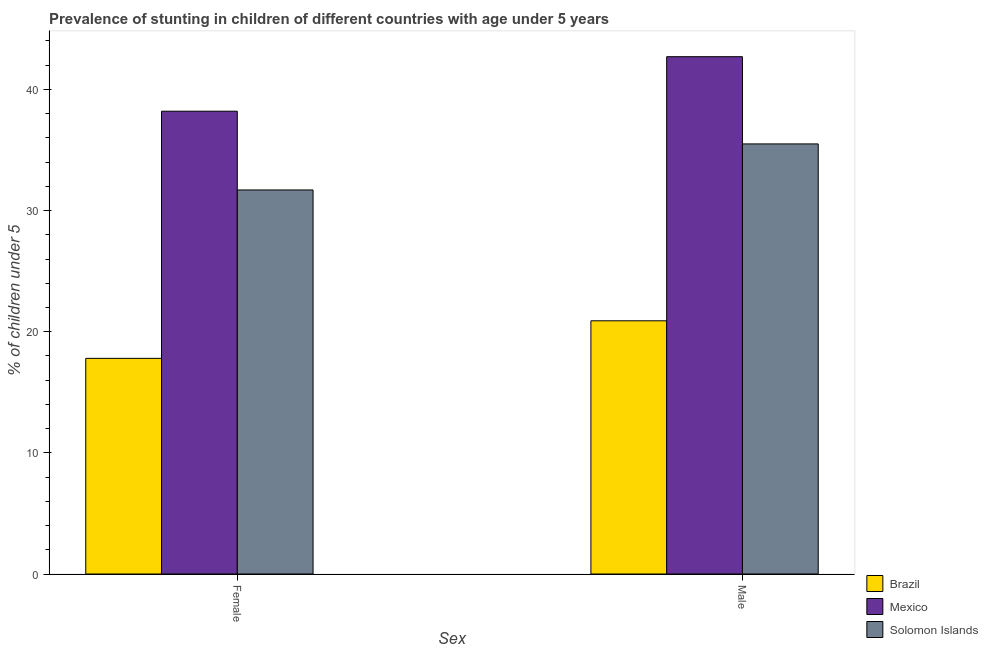How many different coloured bars are there?
Your response must be concise. 3. How many groups of bars are there?
Provide a short and direct response. 2. How many bars are there on the 1st tick from the right?
Keep it short and to the point. 3. What is the label of the 1st group of bars from the left?
Offer a very short reply. Female. What is the percentage of stunted female children in Solomon Islands?
Provide a succinct answer. 31.7. Across all countries, what is the maximum percentage of stunted male children?
Your answer should be compact. 42.7. Across all countries, what is the minimum percentage of stunted female children?
Give a very brief answer. 17.8. What is the total percentage of stunted female children in the graph?
Provide a succinct answer. 87.7. What is the difference between the percentage of stunted male children in Solomon Islands and that in Mexico?
Provide a short and direct response. -7.2. What is the difference between the percentage of stunted male children in Solomon Islands and the percentage of stunted female children in Brazil?
Ensure brevity in your answer.  17.7. What is the average percentage of stunted female children per country?
Your response must be concise. 29.23. What is the difference between the percentage of stunted female children and percentage of stunted male children in Solomon Islands?
Provide a short and direct response. -3.8. What is the ratio of the percentage of stunted female children in Mexico to that in Solomon Islands?
Ensure brevity in your answer.  1.21. Is the percentage of stunted female children in Solomon Islands less than that in Mexico?
Offer a terse response. Yes. What does the 2nd bar from the left in Female represents?
Provide a succinct answer. Mexico. What does the 1st bar from the right in Male represents?
Give a very brief answer. Solomon Islands. How many bars are there?
Your response must be concise. 6. Are all the bars in the graph horizontal?
Provide a short and direct response. No. Are the values on the major ticks of Y-axis written in scientific E-notation?
Keep it short and to the point. No. Does the graph contain any zero values?
Provide a short and direct response. No. Where does the legend appear in the graph?
Offer a terse response. Bottom right. How are the legend labels stacked?
Keep it short and to the point. Vertical. What is the title of the graph?
Your answer should be compact. Prevalence of stunting in children of different countries with age under 5 years. Does "Australia" appear as one of the legend labels in the graph?
Provide a succinct answer. No. What is the label or title of the X-axis?
Provide a short and direct response. Sex. What is the label or title of the Y-axis?
Make the answer very short.  % of children under 5. What is the  % of children under 5 of Brazil in Female?
Ensure brevity in your answer.  17.8. What is the  % of children under 5 of Mexico in Female?
Offer a terse response. 38.2. What is the  % of children under 5 in Solomon Islands in Female?
Your answer should be compact. 31.7. What is the  % of children under 5 in Brazil in Male?
Give a very brief answer. 20.9. What is the  % of children under 5 of Mexico in Male?
Provide a short and direct response. 42.7. What is the  % of children under 5 of Solomon Islands in Male?
Your response must be concise. 35.5. Across all Sex, what is the maximum  % of children under 5 in Brazil?
Your answer should be very brief. 20.9. Across all Sex, what is the maximum  % of children under 5 in Mexico?
Your answer should be compact. 42.7. Across all Sex, what is the maximum  % of children under 5 in Solomon Islands?
Provide a short and direct response. 35.5. Across all Sex, what is the minimum  % of children under 5 of Brazil?
Offer a very short reply. 17.8. Across all Sex, what is the minimum  % of children under 5 in Mexico?
Offer a terse response. 38.2. Across all Sex, what is the minimum  % of children under 5 of Solomon Islands?
Offer a very short reply. 31.7. What is the total  % of children under 5 of Brazil in the graph?
Provide a short and direct response. 38.7. What is the total  % of children under 5 of Mexico in the graph?
Provide a succinct answer. 80.9. What is the total  % of children under 5 in Solomon Islands in the graph?
Make the answer very short. 67.2. What is the difference between the  % of children under 5 in Mexico in Female and that in Male?
Give a very brief answer. -4.5. What is the difference between the  % of children under 5 of Solomon Islands in Female and that in Male?
Offer a terse response. -3.8. What is the difference between the  % of children under 5 in Brazil in Female and the  % of children under 5 in Mexico in Male?
Your answer should be compact. -24.9. What is the difference between the  % of children under 5 of Brazil in Female and the  % of children under 5 of Solomon Islands in Male?
Give a very brief answer. -17.7. What is the difference between the  % of children under 5 in Mexico in Female and the  % of children under 5 in Solomon Islands in Male?
Provide a succinct answer. 2.7. What is the average  % of children under 5 of Brazil per Sex?
Your answer should be very brief. 19.35. What is the average  % of children under 5 in Mexico per Sex?
Provide a succinct answer. 40.45. What is the average  % of children under 5 of Solomon Islands per Sex?
Offer a terse response. 33.6. What is the difference between the  % of children under 5 in Brazil and  % of children under 5 in Mexico in Female?
Ensure brevity in your answer.  -20.4. What is the difference between the  % of children under 5 in Mexico and  % of children under 5 in Solomon Islands in Female?
Your response must be concise. 6.5. What is the difference between the  % of children under 5 in Brazil and  % of children under 5 in Mexico in Male?
Provide a succinct answer. -21.8. What is the difference between the  % of children under 5 in Brazil and  % of children under 5 in Solomon Islands in Male?
Provide a succinct answer. -14.6. What is the ratio of the  % of children under 5 of Brazil in Female to that in Male?
Keep it short and to the point. 0.85. What is the ratio of the  % of children under 5 in Mexico in Female to that in Male?
Your answer should be very brief. 0.89. What is the ratio of the  % of children under 5 of Solomon Islands in Female to that in Male?
Provide a succinct answer. 0.89. What is the difference between the highest and the second highest  % of children under 5 of Solomon Islands?
Offer a very short reply. 3.8. What is the difference between the highest and the lowest  % of children under 5 of Brazil?
Your answer should be compact. 3.1. What is the difference between the highest and the lowest  % of children under 5 of Solomon Islands?
Keep it short and to the point. 3.8. 